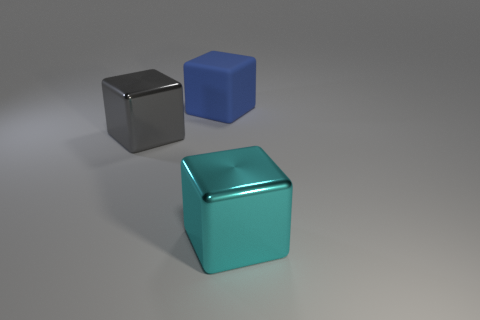What shape is the big thing that is left of the large cyan object and in front of the blue rubber thing?
Make the answer very short. Cube. Does the matte object have the same size as the cyan object?
Your answer should be very brief. Yes. Are there fewer cyan metal objects right of the large blue cube than things that are on the left side of the cyan block?
Offer a very short reply. Yes. Are there any objects in front of the big metal block left of the metallic object that is in front of the big gray thing?
Keep it short and to the point. Yes. Are there any small gray rubber blocks?
Your answer should be compact. No. Is the number of large gray things that are behind the large cyan shiny block greater than the number of big gray things that are behind the big gray object?
Ensure brevity in your answer.  Yes. There is a gray block that is made of the same material as the large cyan thing; what size is it?
Provide a succinct answer. Large. There is a shiny thing behind the thing that is in front of the big block left of the blue object; what size is it?
Your answer should be very brief. Large. The large shiny thing on the left side of the large cyan object is what color?
Provide a succinct answer. Gray. Is the number of large cyan metallic things right of the blue matte thing greater than the number of cyan rubber balls?
Ensure brevity in your answer.  Yes. 